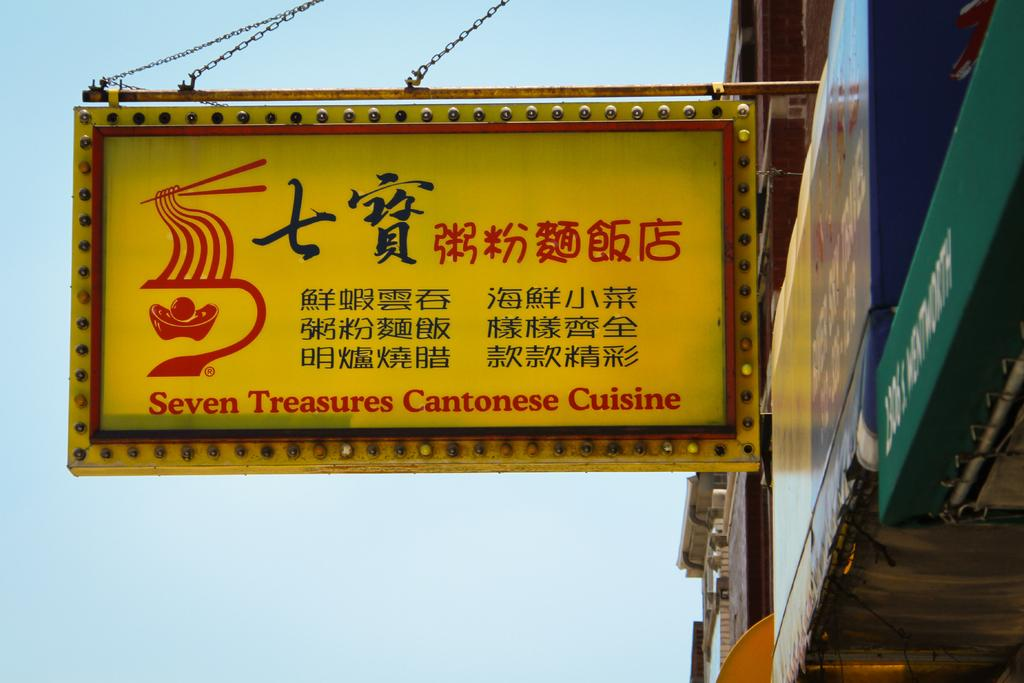What structures are located on the right side of the image? There are buildings and boards on the right side of the image. What is in the middle of the image? There is a hoarding in the middle of the image. What can be seen in the background of the image? The sky is visible in the background of the image. What type of company is advertised on the sun in the image? There is no sun present in the image, and therefore no company can be advertised on it. How many clouds are visible in the image? There are no clouds visible in the image; only the sky is visible in the background. 